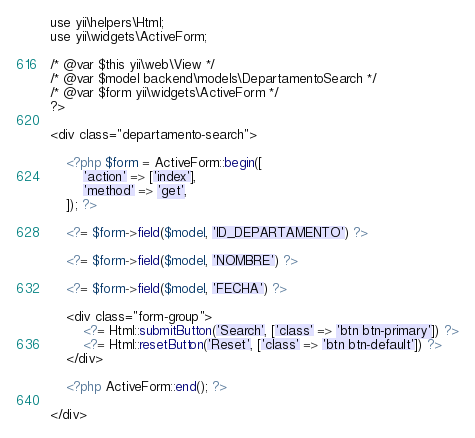<code> <loc_0><loc_0><loc_500><loc_500><_PHP_>use yii\helpers\Html;
use yii\widgets\ActiveForm;

/* @var $this yii\web\View */
/* @var $model backend\models\DepartamentoSearch */
/* @var $form yii\widgets\ActiveForm */
?>

<div class="departamento-search">

    <?php $form = ActiveForm::begin([
        'action' => ['index'],
        'method' => 'get',
    ]); ?>

    <?= $form->field($model, 'ID_DEPARTAMENTO') ?>

    <?= $form->field($model, 'NOMBRE') ?>

    <?= $form->field($model, 'FECHA') ?>

    <div class="form-group">
        <?= Html::submitButton('Search', ['class' => 'btn btn-primary']) ?>
        <?= Html::resetButton('Reset', ['class' => 'btn btn-default']) ?>
    </div>

    <?php ActiveForm::end(); ?>

</div>
</code> 